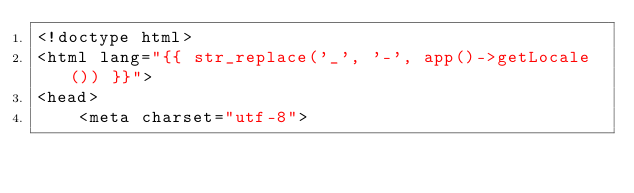Convert code to text. <code><loc_0><loc_0><loc_500><loc_500><_PHP_><!doctype html>
<html lang="{{ str_replace('_', '-', app()->getLocale()) }}">
<head>
    <meta charset="utf-8"></code> 